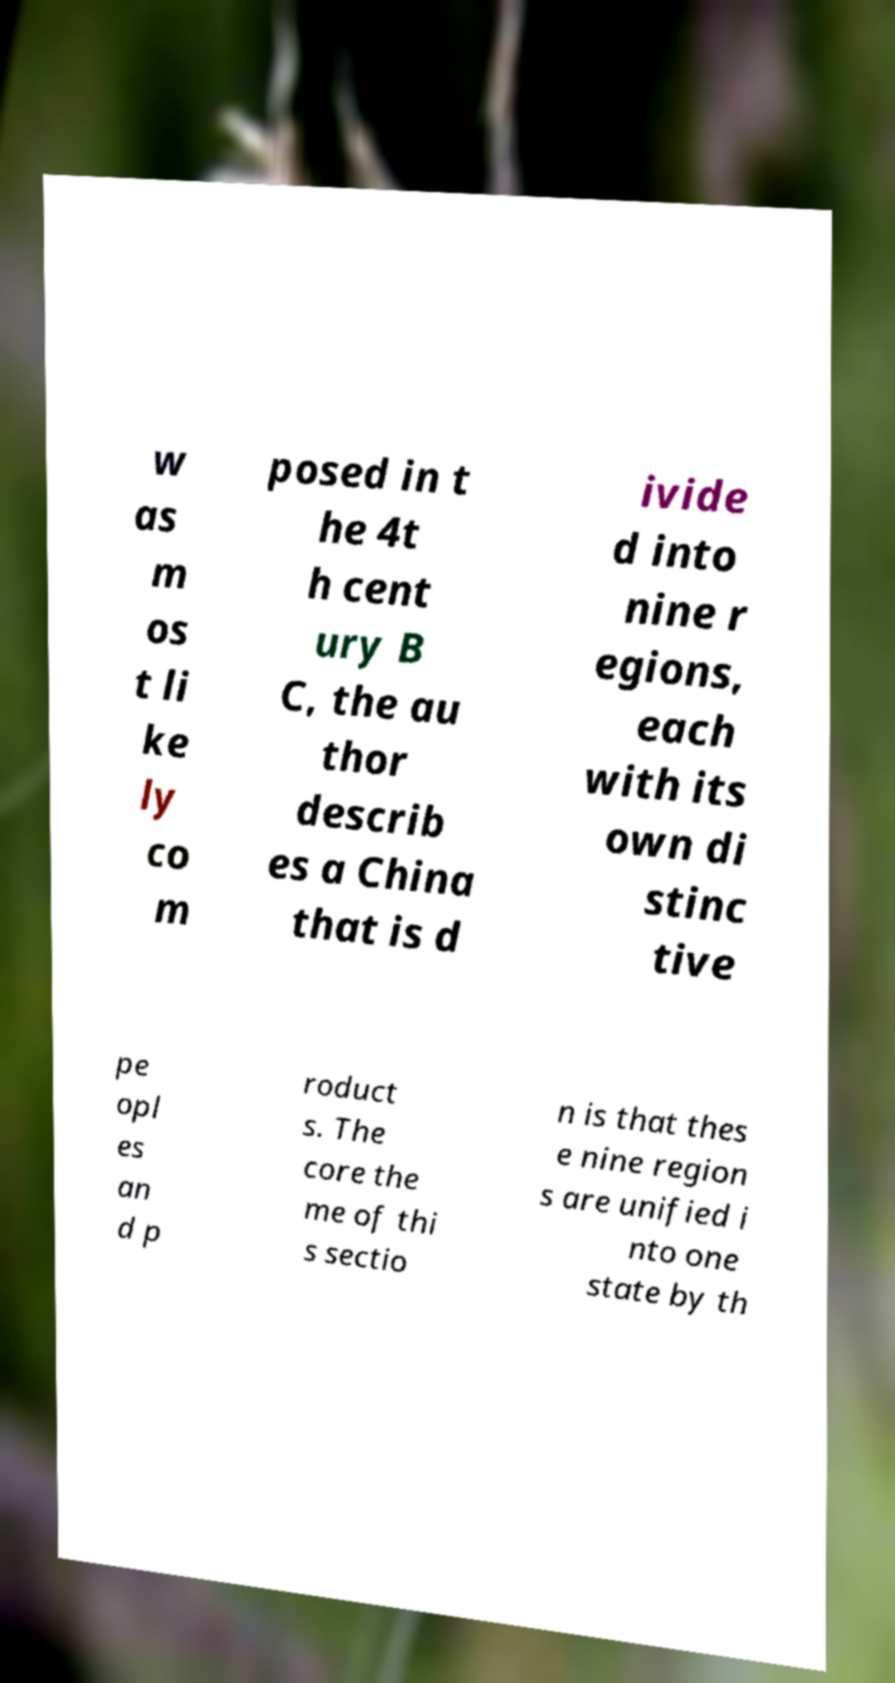There's text embedded in this image that I need extracted. Can you transcribe it verbatim? w as m os t li ke ly co m posed in t he 4t h cent ury B C, the au thor describ es a China that is d ivide d into nine r egions, each with its own di stinc tive pe opl es an d p roduct s. The core the me of thi s sectio n is that thes e nine region s are unified i nto one state by th 